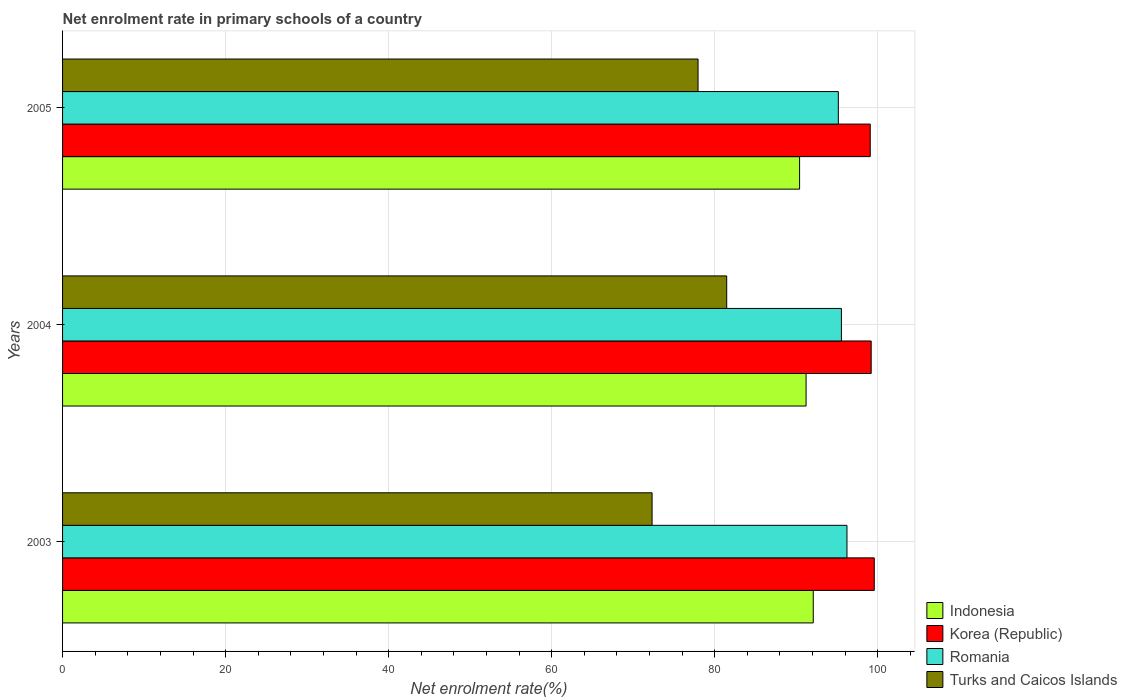How many groups of bars are there?
Keep it short and to the point. 3. Are the number of bars per tick equal to the number of legend labels?
Provide a succinct answer. Yes. How many bars are there on the 3rd tick from the top?
Ensure brevity in your answer.  4. How many bars are there on the 1st tick from the bottom?
Your response must be concise. 4. What is the net enrolment rate in primary schools in Korea (Republic) in 2004?
Your response must be concise. 99.19. Across all years, what is the maximum net enrolment rate in primary schools in Turks and Caicos Islands?
Offer a very short reply. 81.47. Across all years, what is the minimum net enrolment rate in primary schools in Indonesia?
Offer a terse response. 90.41. In which year was the net enrolment rate in primary schools in Romania maximum?
Provide a short and direct response. 2003. What is the total net enrolment rate in primary schools in Korea (Republic) in the graph?
Ensure brevity in your answer.  297.84. What is the difference between the net enrolment rate in primary schools in Indonesia in 2004 and that in 2005?
Give a very brief answer. 0.8. What is the difference between the net enrolment rate in primary schools in Turks and Caicos Islands in 2004 and the net enrolment rate in primary schools in Romania in 2005?
Ensure brevity in your answer.  -13.69. What is the average net enrolment rate in primary schools in Korea (Republic) per year?
Ensure brevity in your answer.  99.28. In the year 2004, what is the difference between the net enrolment rate in primary schools in Indonesia and net enrolment rate in primary schools in Turks and Caicos Islands?
Your answer should be compact. 9.74. What is the ratio of the net enrolment rate in primary schools in Indonesia in 2004 to that in 2005?
Ensure brevity in your answer.  1.01. What is the difference between the highest and the second highest net enrolment rate in primary schools in Korea (Republic)?
Keep it short and to the point. 0.38. What is the difference between the highest and the lowest net enrolment rate in primary schools in Korea (Republic)?
Give a very brief answer. 0.49. What does the 2nd bar from the top in 2004 represents?
Your response must be concise. Romania. What does the 4th bar from the bottom in 2004 represents?
Keep it short and to the point. Turks and Caicos Islands. Is it the case that in every year, the sum of the net enrolment rate in primary schools in Romania and net enrolment rate in primary schools in Turks and Caicos Islands is greater than the net enrolment rate in primary schools in Indonesia?
Offer a very short reply. Yes. Are all the bars in the graph horizontal?
Keep it short and to the point. Yes. What is the difference between two consecutive major ticks on the X-axis?
Your answer should be very brief. 20. Does the graph contain any zero values?
Provide a succinct answer. No. Where does the legend appear in the graph?
Provide a succinct answer. Bottom right. How are the legend labels stacked?
Your response must be concise. Vertical. What is the title of the graph?
Offer a terse response. Net enrolment rate in primary schools of a country. Does "Switzerland" appear as one of the legend labels in the graph?
Your response must be concise. No. What is the label or title of the X-axis?
Keep it short and to the point. Net enrolment rate(%). What is the Net enrolment rate(%) of Indonesia in 2003?
Your answer should be compact. 92.09. What is the Net enrolment rate(%) in Korea (Republic) in 2003?
Offer a terse response. 99.57. What is the Net enrolment rate(%) in Romania in 2003?
Your answer should be compact. 96.22. What is the Net enrolment rate(%) of Turks and Caicos Islands in 2003?
Offer a very short reply. 72.32. What is the Net enrolment rate(%) in Indonesia in 2004?
Give a very brief answer. 91.21. What is the Net enrolment rate(%) in Korea (Republic) in 2004?
Ensure brevity in your answer.  99.19. What is the Net enrolment rate(%) in Romania in 2004?
Provide a succinct answer. 95.54. What is the Net enrolment rate(%) of Turks and Caicos Islands in 2004?
Provide a succinct answer. 81.47. What is the Net enrolment rate(%) in Indonesia in 2005?
Offer a terse response. 90.41. What is the Net enrolment rate(%) in Korea (Republic) in 2005?
Offer a very short reply. 99.08. What is the Net enrolment rate(%) of Romania in 2005?
Your answer should be very brief. 95.16. What is the Net enrolment rate(%) in Turks and Caicos Islands in 2005?
Offer a terse response. 77.95. Across all years, what is the maximum Net enrolment rate(%) in Indonesia?
Provide a short and direct response. 92.09. Across all years, what is the maximum Net enrolment rate(%) of Korea (Republic)?
Your answer should be compact. 99.57. Across all years, what is the maximum Net enrolment rate(%) of Romania?
Make the answer very short. 96.22. Across all years, what is the maximum Net enrolment rate(%) in Turks and Caicos Islands?
Your answer should be very brief. 81.47. Across all years, what is the minimum Net enrolment rate(%) of Indonesia?
Keep it short and to the point. 90.41. Across all years, what is the minimum Net enrolment rate(%) of Korea (Republic)?
Offer a very short reply. 99.08. Across all years, what is the minimum Net enrolment rate(%) in Romania?
Ensure brevity in your answer.  95.16. Across all years, what is the minimum Net enrolment rate(%) in Turks and Caicos Islands?
Provide a succinct answer. 72.32. What is the total Net enrolment rate(%) in Indonesia in the graph?
Give a very brief answer. 273.71. What is the total Net enrolment rate(%) in Korea (Republic) in the graph?
Make the answer very short. 297.84. What is the total Net enrolment rate(%) in Romania in the graph?
Provide a succinct answer. 286.92. What is the total Net enrolment rate(%) of Turks and Caicos Islands in the graph?
Provide a succinct answer. 231.74. What is the difference between the Net enrolment rate(%) of Indonesia in 2003 and that in 2004?
Offer a very short reply. 0.88. What is the difference between the Net enrolment rate(%) of Korea (Republic) in 2003 and that in 2004?
Provide a succinct answer. 0.38. What is the difference between the Net enrolment rate(%) in Romania in 2003 and that in 2004?
Keep it short and to the point. 0.68. What is the difference between the Net enrolment rate(%) of Turks and Caicos Islands in 2003 and that in 2004?
Ensure brevity in your answer.  -9.15. What is the difference between the Net enrolment rate(%) in Indonesia in 2003 and that in 2005?
Make the answer very short. 1.68. What is the difference between the Net enrolment rate(%) of Korea (Republic) in 2003 and that in 2005?
Provide a succinct answer. 0.49. What is the difference between the Net enrolment rate(%) of Romania in 2003 and that in 2005?
Ensure brevity in your answer.  1.06. What is the difference between the Net enrolment rate(%) in Turks and Caicos Islands in 2003 and that in 2005?
Make the answer very short. -5.64. What is the difference between the Net enrolment rate(%) in Indonesia in 2004 and that in 2005?
Your answer should be very brief. 0.8. What is the difference between the Net enrolment rate(%) in Korea (Republic) in 2004 and that in 2005?
Provide a succinct answer. 0.11. What is the difference between the Net enrolment rate(%) in Romania in 2004 and that in 2005?
Your response must be concise. 0.38. What is the difference between the Net enrolment rate(%) in Turks and Caicos Islands in 2004 and that in 2005?
Your response must be concise. 3.52. What is the difference between the Net enrolment rate(%) of Indonesia in 2003 and the Net enrolment rate(%) of Korea (Republic) in 2004?
Ensure brevity in your answer.  -7.1. What is the difference between the Net enrolment rate(%) of Indonesia in 2003 and the Net enrolment rate(%) of Romania in 2004?
Provide a succinct answer. -3.45. What is the difference between the Net enrolment rate(%) in Indonesia in 2003 and the Net enrolment rate(%) in Turks and Caicos Islands in 2004?
Provide a short and direct response. 10.62. What is the difference between the Net enrolment rate(%) of Korea (Republic) in 2003 and the Net enrolment rate(%) of Romania in 2004?
Your answer should be very brief. 4.03. What is the difference between the Net enrolment rate(%) of Korea (Republic) in 2003 and the Net enrolment rate(%) of Turks and Caicos Islands in 2004?
Make the answer very short. 18.1. What is the difference between the Net enrolment rate(%) in Romania in 2003 and the Net enrolment rate(%) in Turks and Caicos Islands in 2004?
Ensure brevity in your answer.  14.75. What is the difference between the Net enrolment rate(%) of Indonesia in 2003 and the Net enrolment rate(%) of Korea (Republic) in 2005?
Give a very brief answer. -6.99. What is the difference between the Net enrolment rate(%) of Indonesia in 2003 and the Net enrolment rate(%) of Romania in 2005?
Keep it short and to the point. -3.07. What is the difference between the Net enrolment rate(%) in Indonesia in 2003 and the Net enrolment rate(%) in Turks and Caicos Islands in 2005?
Provide a succinct answer. 14.14. What is the difference between the Net enrolment rate(%) in Korea (Republic) in 2003 and the Net enrolment rate(%) in Romania in 2005?
Offer a very short reply. 4.41. What is the difference between the Net enrolment rate(%) in Korea (Republic) in 2003 and the Net enrolment rate(%) in Turks and Caicos Islands in 2005?
Your response must be concise. 21.62. What is the difference between the Net enrolment rate(%) of Romania in 2003 and the Net enrolment rate(%) of Turks and Caicos Islands in 2005?
Your response must be concise. 18.27. What is the difference between the Net enrolment rate(%) in Indonesia in 2004 and the Net enrolment rate(%) in Korea (Republic) in 2005?
Offer a very short reply. -7.87. What is the difference between the Net enrolment rate(%) of Indonesia in 2004 and the Net enrolment rate(%) of Romania in 2005?
Provide a succinct answer. -3.96. What is the difference between the Net enrolment rate(%) of Indonesia in 2004 and the Net enrolment rate(%) of Turks and Caicos Islands in 2005?
Offer a terse response. 13.25. What is the difference between the Net enrolment rate(%) in Korea (Republic) in 2004 and the Net enrolment rate(%) in Romania in 2005?
Make the answer very short. 4.03. What is the difference between the Net enrolment rate(%) of Korea (Republic) in 2004 and the Net enrolment rate(%) of Turks and Caicos Islands in 2005?
Give a very brief answer. 21.24. What is the difference between the Net enrolment rate(%) of Romania in 2004 and the Net enrolment rate(%) of Turks and Caicos Islands in 2005?
Provide a short and direct response. 17.59. What is the average Net enrolment rate(%) of Indonesia per year?
Your response must be concise. 91.24. What is the average Net enrolment rate(%) in Korea (Republic) per year?
Your response must be concise. 99.28. What is the average Net enrolment rate(%) of Romania per year?
Your response must be concise. 95.64. What is the average Net enrolment rate(%) of Turks and Caicos Islands per year?
Provide a succinct answer. 77.25. In the year 2003, what is the difference between the Net enrolment rate(%) in Indonesia and Net enrolment rate(%) in Korea (Republic)?
Give a very brief answer. -7.48. In the year 2003, what is the difference between the Net enrolment rate(%) in Indonesia and Net enrolment rate(%) in Romania?
Offer a terse response. -4.13. In the year 2003, what is the difference between the Net enrolment rate(%) of Indonesia and Net enrolment rate(%) of Turks and Caicos Islands?
Your response must be concise. 19.77. In the year 2003, what is the difference between the Net enrolment rate(%) of Korea (Republic) and Net enrolment rate(%) of Romania?
Your response must be concise. 3.35. In the year 2003, what is the difference between the Net enrolment rate(%) of Korea (Republic) and Net enrolment rate(%) of Turks and Caicos Islands?
Offer a very short reply. 27.26. In the year 2003, what is the difference between the Net enrolment rate(%) in Romania and Net enrolment rate(%) in Turks and Caicos Islands?
Your answer should be compact. 23.91. In the year 2004, what is the difference between the Net enrolment rate(%) in Indonesia and Net enrolment rate(%) in Korea (Republic)?
Give a very brief answer. -7.99. In the year 2004, what is the difference between the Net enrolment rate(%) of Indonesia and Net enrolment rate(%) of Romania?
Provide a short and direct response. -4.33. In the year 2004, what is the difference between the Net enrolment rate(%) of Indonesia and Net enrolment rate(%) of Turks and Caicos Islands?
Your answer should be compact. 9.74. In the year 2004, what is the difference between the Net enrolment rate(%) of Korea (Republic) and Net enrolment rate(%) of Romania?
Make the answer very short. 3.65. In the year 2004, what is the difference between the Net enrolment rate(%) in Korea (Republic) and Net enrolment rate(%) in Turks and Caicos Islands?
Your answer should be compact. 17.72. In the year 2004, what is the difference between the Net enrolment rate(%) of Romania and Net enrolment rate(%) of Turks and Caicos Islands?
Your response must be concise. 14.07. In the year 2005, what is the difference between the Net enrolment rate(%) of Indonesia and Net enrolment rate(%) of Korea (Republic)?
Provide a succinct answer. -8.67. In the year 2005, what is the difference between the Net enrolment rate(%) in Indonesia and Net enrolment rate(%) in Romania?
Keep it short and to the point. -4.75. In the year 2005, what is the difference between the Net enrolment rate(%) of Indonesia and Net enrolment rate(%) of Turks and Caicos Islands?
Give a very brief answer. 12.46. In the year 2005, what is the difference between the Net enrolment rate(%) in Korea (Republic) and Net enrolment rate(%) in Romania?
Provide a succinct answer. 3.91. In the year 2005, what is the difference between the Net enrolment rate(%) of Korea (Republic) and Net enrolment rate(%) of Turks and Caicos Islands?
Make the answer very short. 21.12. In the year 2005, what is the difference between the Net enrolment rate(%) in Romania and Net enrolment rate(%) in Turks and Caicos Islands?
Give a very brief answer. 17.21. What is the ratio of the Net enrolment rate(%) of Indonesia in 2003 to that in 2004?
Give a very brief answer. 1.01. What is the ratio of the Net enrolment rate(%) in Romania in 2003 to that in 2004?
Ensure brevity in your answer.  1.01. What is the ratio of the Net enrolment rate(%) in Turks and Caicos Islands in 2003 to that in 2004?
Make the answer very short. 0.89. What is the ratio of the Net enrolment rate(%) of Indonesia in 2003 to that in 2005?
Provide a succinct answer. 1.02. What is the ratio of the Net enrolment rate(%) in Romania in 2003 to that in 2005?
Give a very brief answer. 1.01. What is the ratio of the Net enrolment rate(%) of Turks and Caicos Islands in 2003 to that in 2005?
Keep it short and to the point. 0.93. What is the ratio of the Net enrolment rate(%) in Indonesia in 2004 to that in 2005?
Your answer should be compact. 1.01. What is the ratio of the Net enrolment rate(%) of Turks and Caicos Islands in 2004 to that in 2005?
Ensure brevity in your answer.  1.05. What is the difference between the highest and the second highest Net enrolment rate(%) in Indonesia?
Provide a short and direct response. 0.88. What is the difference between the highest and the second highest Net enrolment rate(%) in Korea (Republic)?
Give a very brief answer. 0.38. What is the difference between the highest and the second highest Net enrolment rate(%) of Romania?
Your answer should be very brief. 0.68. What is the difference between the highest and the second highest Net enrolment rate(%) in Turks and Caicos Islands?
Offer a very short reply. 3.52. What is the difference between the highest and the lowest Net enrolment rate(%) of Indonesia?
Give a very brief answer. 1.68. What is the difference between the highest and the lowest Net enrolment rate(%) of Korea (Republic)?
Offer a terse response. 0.49. What is the difference between the highest and the lowest Net enrolment rate(%) of Romania?
Provide a short and direct response. 1.06. What is the difference between the highest and the lowest Net enrolment rate(%) of Turks and Caicos Islands?
Make the answer very short. 9.15. 